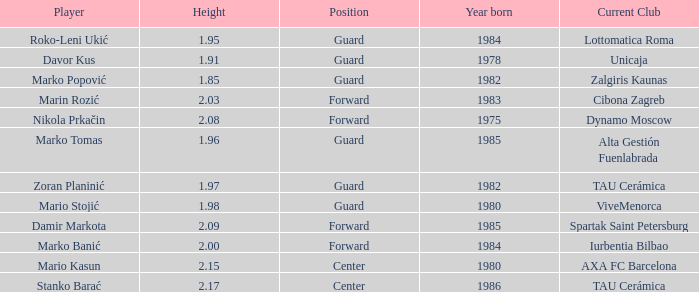What is the tallness of the athlete who presently performs for alta gestión fuenlabrada? 1.96. 